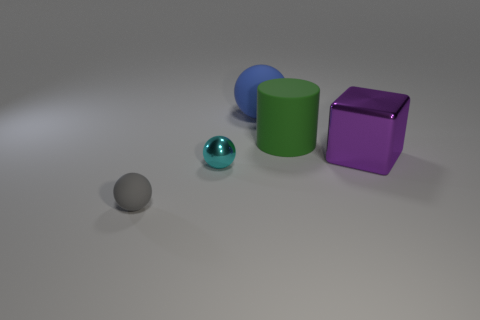There is a thing that is to the left of the tiny shiny thing; what shape is it?
Make the answer very short. Sphere. What number of things are tiny cyan metal spheres or things that are left of the green thing?
Provide a succinct answer. 3. Are the large block and the green cylinder made of the same material?
Provide a short and direct response. No. Are there an equal number of tiny matte objects that are to the right of the large green cylinder and blocks to the right of the big purple metallic thing?
Provide a succinct answer. Yes. What number of large things are on the right side of the big matte sphere?
Ensure brevity in your answer.  2. How many things are big blocks or cylinders?
Your response must be concise. 2. What number of other gray spheres have the same size as the gray sphere?
Offer a terse response. 0. There is a metal object behind the small thing behind the gray ball; what is its shape?
Keep it short and to the point. Cube. Is the number of blue matte cylinders less than the number of large cylinders?
Your answer should be very brief. Yes. There is a metal object that is to the left of the purple metal object; what color is it?
Make the answer very short. Cyan. 